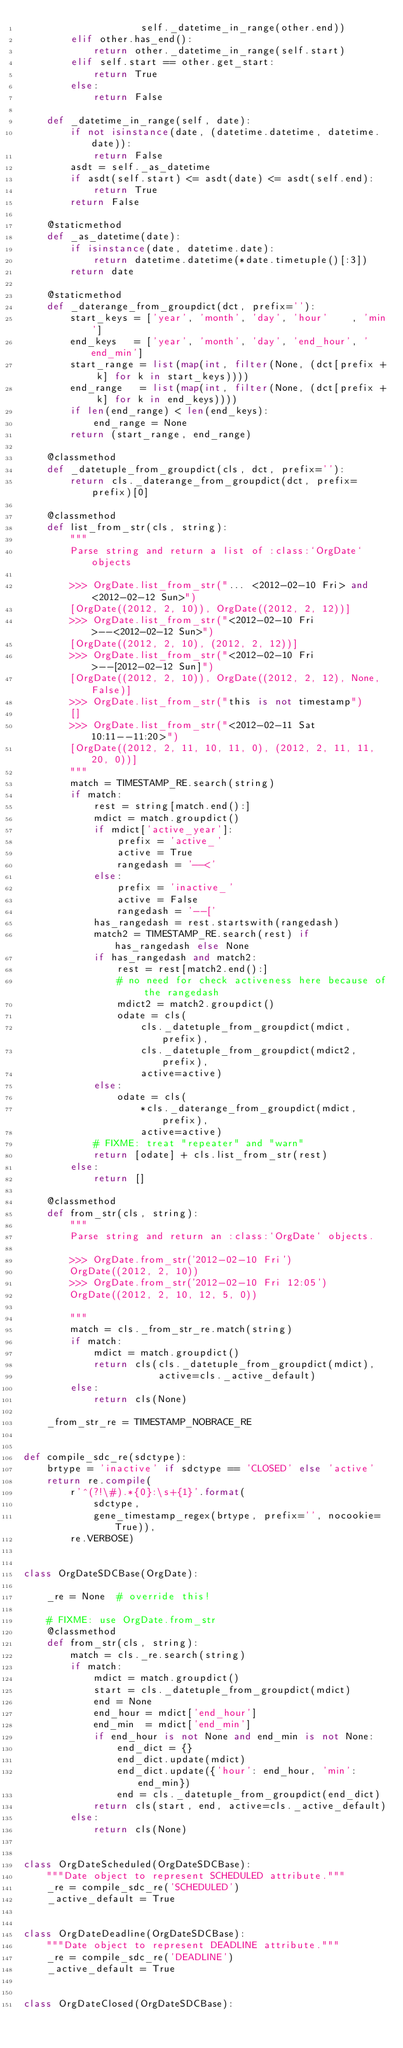Convert code to text. <code><loc_0><loc_0><loc_500><loc_500><_Python_>                    self._datetime_in_range(other.end))
        elif other.has_end():
            return other._datetime_in_range(self.start)
        elif self.start == other.get_start:
            return True
        else:
            return False

    def _datetime_in_range(self, date):
        if not isinstance(date, (datetime.datetime, datetime.date)):
            return False
        asdt = self._as_datetime
        if asdt(self.start) <= asdt(date) <= asdt(self.end):
            return True
        return False

    @staticmethod
    def _as_datetime(date):
        if isinstance(date, datetime.date):
            return datetime.datetime(*date.timetuple()[:3])
        return date

    @staticmethod
    def _daterange_from_groupdict(dct, prefix=''):
        start_keys = ['year', 'month', 'day', 'hour'    , 'min']
        end_keys   = ['year', 'month', 'day', 'end_hour', 'end_min']
        start_range = list(map(int, filter(None, (dct[prefix + k] for k in start_keys))))
        end_range   = list(map(int, filter(None, (dct[prefix + k] for k in end_keys))))
        if len(end_range) < len(end_keys):
            end_range = None
        return (start_range, end_range)

    @classmethod
    def _datetuple_from_groupdict(cls, dct, prefix=''):
        return cls._daterange_from_groupdict(dct, prefix=prefix)[0]

    @classmethod
    def list_from_str(cls, string):
        """
        Parse string and return a list of :class:`OrgDate` objects

        >>> OrgDate.list_from_str("... <2012-02-10 Fri> and <2012-02-12 Sun>")
        [OrgDate((2012, 2, 10)), OrgDate((2012, 2, 12))]
        >>> OrgDate.list_from_str("<2012-02-10 Fri>--<2012-02-12 Sun>")
        [OrgDate((2012, 2, 10), (2012, 2, 12))]
        >>> OrgDate.list_from_str("<2012-02-10 Fri>--[2012-02-12 Sun]")
        [OrgDate((2012, 2, 10)), OrgDate((2012, 2, 12), None, False)]
        >>> OrgDate.list_from_str("this is not timestamp")
        []
        >>> OrgDate.list_from_str("<2012-02-11 Sat 10:11--11:20>")
        [OrgDate((2012, 2, 11, 10, 11, 0), (2012, 2, 11, 11, 20, 0))]
        """
        match = TIMESTAMP_RE.search(string)
        if match:
            rest = string[match.end():]
            mdict = match.groupdict()
            if mdict['active_year']:
                prefix = 'active_'
                active = True
                rangedash = '--<'
            else:
                prefix = 'inactive_'
                active = False
                rangedash = '--['
            has_rangedash = rest.startswith(rangedash)
            match2 = TIMESTAMP_RE.search(rest) if has_rangedash else None
            if has_rangedash and match2:
                rest = rest[match2.end():]
                # no need for check activeness here because of the rangedash
                mdict2 = match2.groupdict()
                odate = cls(
                    cls._datetuple_from_groupdict(mdict, prefix),
                    cls._datetuple_from_groupdict(mdict2, prefix),
                    active=active)
            else:
                odate = cls(
                    *cls._daterange_from_groupdict(mdict, prefix),
                    active=active)
            # FIXME: treat "repeater" and "warn"
            return [odate] + cls.list_from_str(rest)
        else:
            return []

    @classmethod
    def from_str(cls, string):
        """
        Parse string and return an :class:`OrgDate` objects.

        >>> OrgDate.from_str('2012-02-10 Fri')
        OrgDate((2012, 2, 10))
        >>> OrgDate.from_str('2012-02-10 Fri 12:05')
        OrgDate((2012, 2, 10, 12, 5, 0))

        """
        match = cls._from_str_re.match(string)
        if match:
            mdict = match.groupdict()
            return cls(cls._datetuple_from_groupdict(mdict),
                       active=cls._active_default)
        else:
            return cls(None)

    _from_str_re = TIMESTAMP_NOBRACE_RE


def compile_sdc_re(sdctype):
    brtype = 'inactive' if sdctype == 'CLOSED' else 'active'
    return re.compile(
        r'^(?!\#).*{0}:\s+{1}'.format(
            sdctype,
            gene_timestamp_regex(brtype, prefix='', nocookie=True)),
        re.VERBOSE)


class OrgDateSDCBase(OrgDate):

    _re = None  # override this!

    # FIXME: use OrgDate.from_str
    @classmethod
    def from_str(cls, string):
        match = cls._re.search(string)
        if match:
            mdict = match.groupdict()
            start = cls._datetuple_from_groupdict(mdict)
            end = None
            end_hour = mdict['end_hour']
            end_min  = mdict['end_min']
            if end_hour is not None and end_min is not None:
                end_dict = {}
                end_dict.update(mdict)
                end_dict.update({'hour': end_hour, 'min': end_min})
                end = cls._datetuple_from_groupdict(end_dict)
            return cls(start, end, active=cls._active_default)
        else:
            return cls(None)


class OrgDateScheduled(OrgDateSDCBase):
    """Date object to represent SCHEDULED attribute."""
    _re = compile_sdc_re('SCHEDULED')
    _active_default = True


class OrgDateDeadline(OrgDateSDCBase):
    """Date object to represent DEADLINE attribute."""
    _re = compile_sdc_re('DEADLINE')
    _active_default = True


class OrgDateClosed(OrgDateSDCBase):</code> 